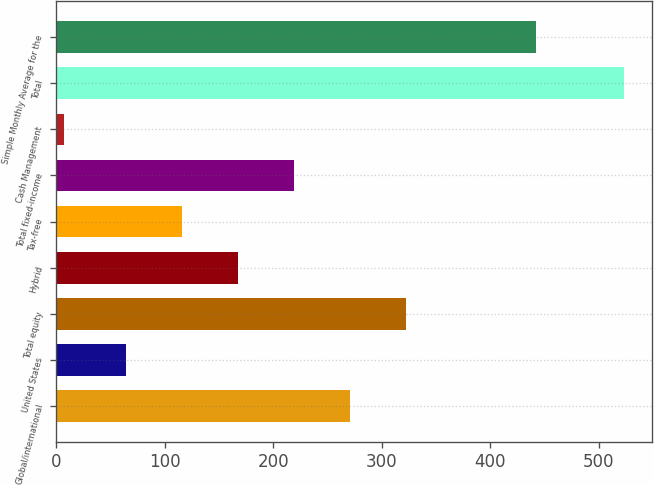Convert chart. <chart><loc_0><loc_0><loc_500><loc_500><bar_chart><fcel>Global/international<fcel>United States<fcel>Total equity<fcel>Hybrid<fcel>Tax-free<fcel>Total fixed-income<fcel>Cash Management<fcel>Total<fcel>Simple Monthly Average for the<nl><fcel>270.5<fcel>63.9<fcel>322.15<fcel>167.2<fcel>115.55<fcel>218.85<fcel>6.9<fcel>523.4<fcel>442.2<nl></chart> 